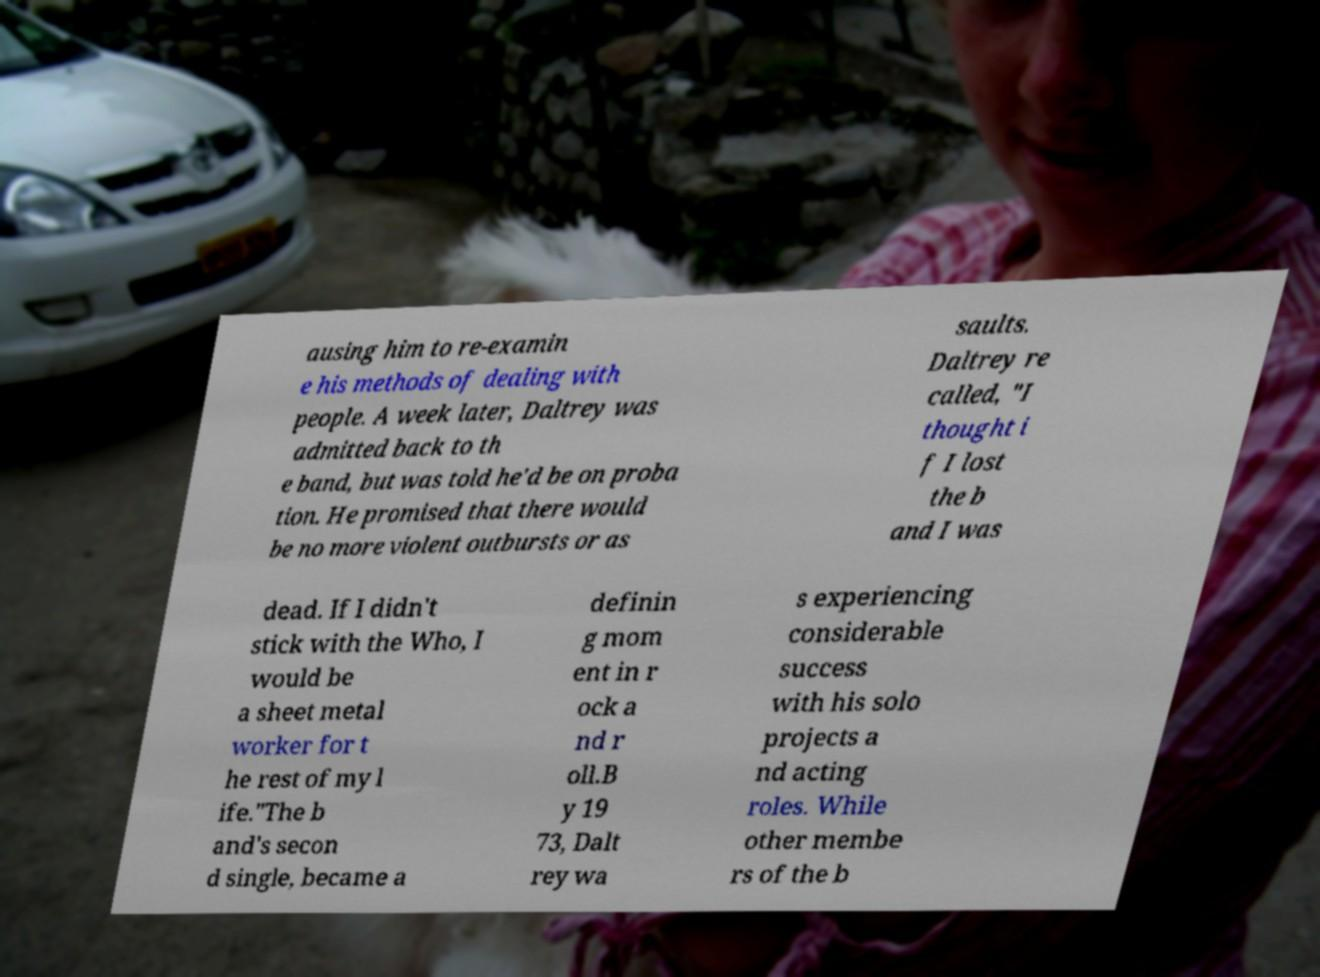What messages or text are displayed in this image? I need them in a readable, typed format. ausing him to re-examin e his methods of dealing with people. A week later, Daltrey was admitted back to th e band, but was told he'd be on proba tion. He promised that there would be no more violent outbursts or as saults. Daltrey re called, "I thought i f I lost the b and I was dead. If I didn't stick with the Who, I would be a sheet metal worker for t he rest of my l ife."The b and's secon d single, became a definin g mom ent in r ock a nd r oll.B y 19 73, Dalt rey wa s experiencing considerable success with his solo projects a nd acting roles. While other membe rs of the b 